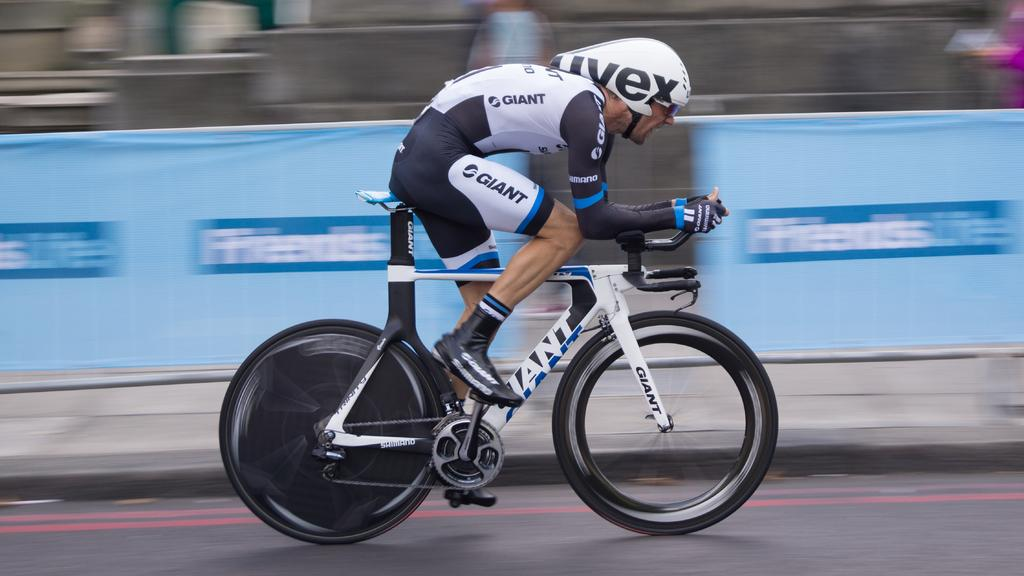<image>
Write a terse but informative summary of the picture. a bike racer in a black, white and blue GIANT uniform 